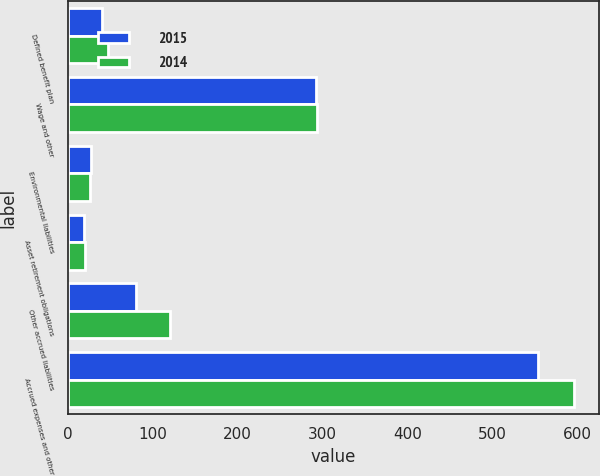Convert chart to OTSL. <chart><loc_0><loc_0><loc_500><loc_500><stacked_bar_chart><ecel><fcel>Defined benefit plan<fcel>Wage and other<fcel>Environmental liabilities<fcel>Asset retirement obligations<fcel>Other accrued liabilities<fcel>Accrued expenses and other<nl><fcel>2015<fcel>40<fcel>292<fcel>27<fcel>19<fcel>80<fcel>554<nl><fcel>2014<fcel>48<fcel>294<fcel>26<fcel>20<fcel>120<fcel>596<nl></chart> 